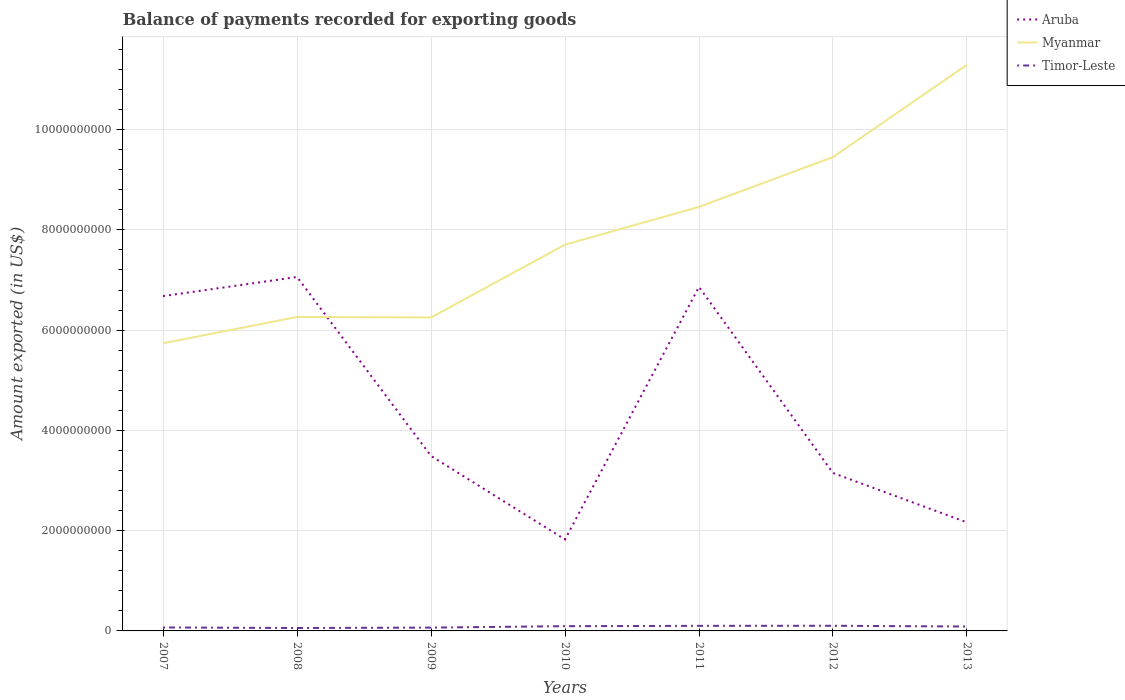Is the number of lines equal to the number of legend labels?
Provide a short and direct response. Yes. Across all years, what is the maximum amount exported in Myanmar?
Give a very brief answer. 5.74e+09. What is the total amount exported in Aruba in the graph?
Ensure brevity in your answer.  -3.82e+08. What is the difference between the highest and the second highest amount exported in Timor-Leste?
Your response must be concise. 4.45e+07. How many years are there in the graph?
Keep it short and to the point. 7. What is the difference between two consecutive major ticks on the Y-axis?
Offer a very short reply. 2.00e+09. How many legend labels are there?
Your answer should be very brief. 3. What is the title of the graph?
Your answer should be compact. Balance of payments recorded for exporting goods. Does "Northern Mariana Islands" appear as one of the legend labels in the graph?
Give a very brief answer. No. What is the label or title of the X-axis?
Ensure brevity in your answer.  Years. What is the label or title of the Y-axis?
Offer a terse response. Amount exported (in US$). What is the Amount exported (in US$) of Aruba in 2007?
Offer a terse response. 6.68e+09. What is the Amount exported (in US$) in Myanmar in 2007?
Your answer should be very brief. 5.74e+09. What is the Amount exported (in US$) in Timor-Leste in 2007?
Your answer should be compact. 6.92e+07. What is the Amount exported (in US$) of Aruba in 2008?
Your response must be concise. 7.06e+09. What is the Amount exported (in US$) in Myanmar in 2008?
Offer a very short reply. 6.26e+09. What is the Amount exported (in US$) of Timor-Leste in 2008?
Your answer should be very brief. 5.81e+07. What is the Amount exported (in US$) of Aruba in 2009?
Your response must be concise. 3.49e+09. What is the Amount exported (in US$) of Myanmar in 2009?
Your answer should be compact. 6.25e+09. What is the Amount exported (in US$) in Timor-Leste in 2009?
Provide a succinct answer. 6.61e+07. What is the Amount exported (in US$) in Aruba in 2010?
Give a very brief answer. 1.82e+09. What is the Amount exported (in US$) in Myanmar in 2010?
Offer a terse response. 7.70e+09. What is the Amount exported (in US$) of Timor-Leste in 2010?
Provide a succinct answer. 9.49e+07. What is the Amount exported (in US$) of Aruba in 2011?
Provide a short and direct response. 6.86e+09. What is the Amount exported (in US$) of Myanmar in 2011?
Ensure brevity in your answer.  8.46e+09. What is the Amount exported (in US$) of Timor-Leste in 2011?
Your answer should be very brief. 1.01e+08. What is the Amount exported (in US$) in Aruba in 2012?
Provide a succinct answer. 3.15e+09. What is the Amount exported (in US$) in Myanmar in 2012?
Make the answer very short. 9.45e+09. What is the Amount exported (in US$) in Timor-Leste in 2012?
Your answer should be compact. 1.03e+08. What is the Amount exported (in US$) of Aruba in 2013?
Your response must be concise. 2.16e+09. What is the Amount exported (in US$) in Myanmar in 2013?
Your answer should be very brief. 1.13e+1. What is the Amount exported (in US$) of Timor-Leste in 2013?
Keep it short and to the point. 8.79e+07. Across all years, what is the maximum Amount exported (in US$) in Aruba?
Your answer should be very brief. 7.06e+09. Across all years, what is the maximum Amount exported (in US$) in Myanmar?
Offer a very short reply. 1.13e+1. Across all years, what is the maximum Amount exported (in US$) in Timor-Leste?
Offer a very short reply. 1.03e+08. Across all years, what is the minimum Amount exported (in US$) in Aruba?
Your answer should be very brief. 1.82e+09. Across all years, what is the minimum Amount exported (in US$) of Myanmar?
Offer a very short reply. 5.74e+09. Across all years, what is the minimum Amount exported (in US$) in Timor-Leste?
Make the answer very short. 5.81e+07. What is the total Amount exported (in US$) in Aruba in the graph?
Give a very brief answer. 3.12e+1. What is the total Amount exported (in US$) in Myanmar in the graph?
Provide a succinct answer. 5.52e+1. What is the total Amount exported (in US$) in Timor-Leste in the graph?
Keep it short and to the point. 5.80e+08. What is the difference between the Amount exported (in US$) of Aruba in 2007 and that in 2008?
Keep it short and to the point. -3.82e+08. What is the difference between the Amount exported (in US$) in Myanmar in 2007 and that in 2008?
Your answer should be compact. -5.25e+08. What is the difference between the Amount exported (in US$) in Timor-Leste in 2007 and that in 2008?
Your answer should be compact. 1.10e+07. What is the difference between the Amount exported (in US$) of Aruba in 2007 and that in 2009?
Offer a terse response. 3.19e+09. What is the difference between the Amount exported (in US$) of Myanmar in 2007 and that in 2009?
Keep it short and to the point. -5.15e+08. What is the difference between the Amount exported (in US$) in Timor-Leste in 2007 and that in 2009?
Keep it short and to the point. 3.01e+06. What is the difference between the Amount exported (in US$) of Aruba in 2007 and that in 2010?
Offer a terse response. 4.85e+09. What is the difference between the Amount exported (in US$) of Myanmar in 2007 and that in 2010?
Make the answer very short. -1.97e+09. What is the difference between the Amount exported (in US$) of Timor-Leste in 2007 and that in 2010?
Keep it short and to the point. -2.57e+07. What is the difference between the Amount exported (in US$) in Aruba in 2007 and that in 2011?
Provide a short and direct response. -1.83e+08. What is the difference between the Amount exported (in US$) in Myanmar in 2007 and that in 2011?
Make the answer very short. -2.72e+09. What is the difference between the Amount exported (in US$) in Timor-Leste in 2007 and that in 2011?
Your answer should be very brief. -3.21e+07. What is the difference between the Amount exported (in US$) in Aruba in 2007 and that in 2012?
Offer a very short reply. 3.53e+09. What is the difference between the Amount exported (in US$) of Myanmar in 2007 and that in 2012?
Ensure brevity in your answer.  -3.71e+09. What is the difference between the Amount exported (in US$) in Timor-Leste in 2007 and that in 2012?
Your response must be concise. -3.35e+07. What is the difference between the Amount exported (in US$) of Aruba in 2007 and that in 2013?
Your answer should be compact. 4.51e+09. What is the difference between the Amount exported (in US$) in Myanmar in 2007 and that in 2013?
Keep it short and to the point. -5.56e+09. What is the difference between the Amount exported (in US$) in Timor-Leste in 2007 and that in 2013?
Keep it short and to the point. -1.87e+07. What is the difference between the Amount exported (in US$) in Aruba in 2008 and that in 2009?
Make the answer very short. 3.57e+09. What is the difference between the Amount exported (in US$) of Myanmar in 2008 and that in 2009?
Keep it short and to the point. 9.44e+06. What is the difference between the Amount exported (in US$) of Timor-Leste in 2008 and that in 2009?
Your response must be concise. -8.01e+06. What is the difference between the Amount exported (in US$) in Aruba in 2008 and that in 2010?
Keep it short and to the point. 5.24e+09. What is the difference between the Amount exported (in US$) in Myanmar in 2008 and that in 2010?
Provide a succinct answer. -1.44e+09. What is the difference between the Amount exported (in US$) in Timor-Leste in 2008 and that in 2010?
Offer a very short reply. -3.67e+07. What is the difference between the Amount exported (in US$) in Aruba in 2008 and that in 2011?
Your answer should be compact. 1.99e+08. What is the difference between the Amount exported (in US$) in Myanmar in 2008 and that in 2011?
Offer a terse response. -2.20e+09. What is the difference between the Amount exported (in US$) in Timor-Leste in 2008 and that in 2011?
Provide a short and direct response. -4.31e+07. What is the difference between the Amount exported (in US$) of Aruba in 2008 and that in 2012?
Your response must be concise. 3.91e+09. What is the difference between the Amount exported (in US$) of Myanmar in 2008 and that in 2012?
Offer a very short reply. -3.19e+09. What is the difference between the Amount exported (in US$) of Timor-Leste in 2008 and that in 2012?
Your answer should be very brief. -4.45e+07. What is the difference between the Amount exported (in US$) in Aruba in 2008 and that in 2013?
Your answer should be very brief. 4.89e+09. What is the difference between the Amount exported (in US$) in Myanmar in 2008 and that in 2013?
Ensure brevity in your answer.  -5.03e+09. What is the difference between the Amount exported (in US$) of Timor-Leste in 2008 and that in 2013?
Provide a short and direct response. -2.97e+07. What is the difference between the Amount exported (in US$) of Aruba in 2009 and that in 2010?
Provide a succinct answer. 1.67e+09. What is the difference between the Amount exported (in US$) in Myanmar in 2009 and that in 2010?
Your answer should be compact. -1.45e+09. What is the difference between the Amount exported (in US$) in Timor-Leste in 2009 and that in 2010?
Your response must be concise. -2.87e+07. What is the difference between the Amount exported (in US$) in Aruba in 2009 and that in 2011?
Give a very brief answer. -3.37e+09. What is the difference between the Amount exported (in US$) of Myanmar in 2009 and that in 2011?
Your response must be concise. -2.20e+09. What is the difference between the Amount exported (in US$) in Timor-Leste in 2009 and that in 2011?
Provide a short and direct response. -3.51e+07. What is the difference between the Amount exported (in US$) of Aruba in 2009 and that in 2012?
Ensure brevity in your answer.  3.40e+08. What is the difference between the Amount exported (in US$) in Myanmar in 2009 and that in 2012?
Your response must be concise. -3.20e+09. What is the difference between the Amount exported (in US$) in Timor-Leste in 2009 and that in 2012?
Your answer should be compact. -3.65e+07. What is the difference between the Amount exported (in US$) in Aruba in 2009 and that in 2013?
Offer a terse response. 1.33e+09. What is the difference between the Amount exported (in US$) in Myanmar in 2009 and that in 2013?
Ensure brevity in your answer.  -5.04e+09. What is the difference between the Amount exported (in US$) in Timor-Leste in 2009 and that in 2013?
Make the answer very short. -2.17e+07. What is the difference between the Amount exported (in US$) in Aruba in 2010 and that in 2011?
Offer a terse response. -5.04e+09. What is the difference between the Amount exported (in US$) in Myanmar in 2010 and that in 2011?
Your answer should be compact. -7.54e+08. What is the difference between the Amount exported (in US$) in Timor-Leste in 2010 and that in 2011?
Give a very brief answer. -6.37e+06. What is the difference between the Amount exported (in US$) of Aruba in 2010 and that in 2012?
Provide a succinct answer. -1.33e+09. What is the difference between the Amount exported (in US$) in Myanmar in 2010 and that in 2012?
Keep it short and to the point. -1.75e+09. What is the difference between the Amount exported (in US$) of Timor-Leste in 2010 and that in 2012?
Your response must be concise. -7.80e+06. What is the difference between the Amount exported (in US$) of Aruba in 2010 and that in 2013?
Your answer should be compact. -3.40e+08. What is the difference between the Amount exported (in US$) of Myanmar in 2010 and that in 2013?
Give a very brief answer. -3.59e+09. What is the difference between the Amount exported (in US$) in Timor-Leste in 2010 and that in 2013?
Keep it short and to the point. 7.03e+06. What is the difference between the Amount exported (in US$) of Aruba in 2011 and that in 2012?
Make the answer very short. 3.71e+09. What is the difference between the Amount exported (in US$) in Myanmar in 2011 and that in 2012?
Give a very brief answer. -9.94e+08. What is the difference between the Amount exported (in US$) in Timor-Leste in 2011 and that in 2012?
Give a very brief answer. -1.43e+06. What is the difference between the Amount exported (in US$) of Aruba in 2011 and that in 2013?
Your response must be concise. 4.70e+09. What is the difference between the Amount exported (in US$) of Myanmar in 2011 and that in 2013?
Keep it short and to the point. -2.84e+09. What is the difference between the Amount exported (in US$) of Timor-Leste in 2011 and that in 2013?
Your answer should be compact. 1.34e+07. What is the difference between the Amount exported (in US$) of Aruba in 2012 and that in 2013?
Provide a succinct answer. 9.85e+08. What is the difference between the Amount exported (in US$) of Myanmar in 2012 and that in 2013?
Offer a very short reply. -1.84e+09. What is the difference between the Amount exported (in US$) in Timor-Leste in 2012 and that in 2013?
Offer a very short reply. 1.48e+07. What is the difference between the Amount exported (in US$) of Aruba in 2007 and the Amount exported (in US$) of Myanmar in 2008?
Provide a succinct answer. 4.16e+08. What is the difference between the Amount exported (in US$) in Aruba in 2007 and the Amount exported (in US$) in Timor-Leste in 2008?
Make the answer very short. 6.62e+09. What is the difference between the Amount exported (in US$) in Myanmar in 2007 and the Amount exported (in US$) in Timor-Leste in 2008?
Your answer should be compact. 5.68e+09. What is the difference between the Amount exported (in US$) of Aruba in 2007 and the Amount exported (in US$) of Myanmar in 2009?
Make the answer very short. 4.25e+08. What is the difference between the Amount exported (in US$) in Aruba in 2007 and the Amount exported (in US$) in Timor-Leste in 2009?
Provide a succinct answer. 6.61e+09. What is the difference between the Amount exported (in US$) in Myanmar in 2007 and the Amount exported (in US$) in Timor-Leste in 2009?
Offer a very short reply. 5.67e+09. What is the difference between the Amount exported (in US$) in Aruba in 2007 and the Amount exported (in US$) in Myanmar in 2010?
Provide a short and direct response. -1.03e+09. What is the difference between the Amount exported (in US$) in Aruba in 2007 and the Amount exported (in US$) in Timor-Leste in 2010?
Your answer should be compact. 6.58e+09. What is the difference between the Amount exported (in US$) of Myanmar in 2007 and the Amount exported (in US$) of Timor-Leste in 2010?
Keep it short and to the point. 5.64e+09. What is the difference between the Amount exported (in US$) in Aruba in 2007 and the Amount exported (in US$) in Myanmar in 2011?
Your answer should be compact. -1.78e+09. What is the difference between the Amount exported (in US$) of Aruba in 2007 and the Amount exported (in US$) of Timor-Leste in 2011?
Provide a short and direct response. 6.58e+09. What is the difference between the Amount exported (in US$) of Myanmar in 2007 and the Amount exported (in US$) of Timor-Leste in 2011?
Provide a succinct answer. 5.64e+09. What is the difference between the Amount exported (in US$) of Aruba in 2007 and the Amount exported (in US$) of Myanmar in 2012?
Keep it short and to the point. -2.77e+09. What is the difference between the Amount exported (in US$) in Aruba in 2007 and the Amount exported (in US$) in Timor-Leste in 2012?
Ensure brevity in your answer.  6.58e+09. What is the difference between the Amount exported (in US$) of Myanmar in 2007 and the Amount exported (in US$) of Timor-Leste in 2012?
Provide a succinct answer. 5.63e+09. What is the difference between the Amount exported (in US$) of Aruba in 2007 and the Amount exported (in US$) of Myanmar in 2013?
Your answer should be compact. -4.62e+09. What is the difference between the Amount exported (in US$) in Aruba in 2007 and the Amount exported (in US$) in Timor-Leste in 2013?
Offer a very short reply. 6.59e+09. What is the difference between the Amount exported (in US$) in Myanmar in 2007 and the Amount exported (in US$) in Timor-Leste in 2013?
Offer a very short reply. 5.65e+09. What is the difference between the Amount exported (in US$) in Aruba in 2008 and the Amount exported (in US$) in Myanmar in 2009?
Your answer should be compact. 8.07e+08. What is the difference between the Amount exported (in US$) in Aruba in 2008 and the Amount exported (in US$) in Timor-Leste in 2009?
Make the answer very short. 6.99e+09. What is the difference between the Amount exported (in US$) in Myanmar in 2008 and the Amount exported (in US$) in Timor-Leste in 2009?
Your answer should be very brief. 6.20e+09. What is the difference between the Amount exported (in US$) of Aruba in 2008 and the Amount exported (in US$) of Myanmar in 2010?
Keep it short and to the point. -6.44e+08. What is the difference between the Amount exported (in US$) of Aruba in 2008 and the Amount exported (in US$) of Timor-Leste in 2010?
Provide a succinct answer. 6.96e+09. What is the difference between the Amount exported (in US$) in Myanmar in 2008 and the Amount exported (in US$) in Timor-Leste in 2010?
Your answer should be very brief. 6.17e+09. What is the difference between the Amount exported (in US$) in Aruba in 2008 and the Amount exported (in US$) in Myanmar in 2011?
Your answer should be compact. -1.40e+09. What is the difference between the Amount exported (in US$) of Aruba in 2008 and the Amount exported (in US$) of Timor-Leste in 2011?
Give a very brief answer. 6.96e+09. What is the difference between the Amount exported (in US$) in Myanmar in 2008 and the Amount exported (in US$) in Timor-Leste in 2011?
Your response must be concise. 6.16e+09. What is the difference between the Amount exported (in US$) in Aruba in 2008 and the Amount exported (in US$) in Myanmar in 2012?
Provide a short and direct response. -2.39e+09. What is the difference between the Amount exported (in US$) in Aruba in 2008 and the Amount exported (in US$) in Timor-Leste in 2012?
Make the answer very short. 6.96e+09. What is the difference between the Amount exported (in US$) in Myanmar in 2008 and the Amount exported (in US$) in Timor-Leste in 2012?
Offer a very short reply. 6.16e+09. What is the difference between the Amount exported (in US$) in Aruba in 2008 and the Amount exported (in US$) in Myanmar in 2013?
Your response must be concise. -4.23e+09. What is the difference between the Amount exported (in US$) of Aruba in 2008 and the Amount exported (in US$) of Timor-Leste in 2013?
Offer a very short reply. 6.97e+09. What is the difference between the Amount exported (in US$) in Myanmar in 2008 and the Amount exported (in US$) in Timor-Leste in 2013?
Your answer should be very brief. 6.17e+09. What is the difference between the Amount exported (in US$) of Aruba in 2009 and the Amount exported (in US$) of Myanmar in 2010?
Ensure brevity in your answer.  -4.21e+09. What is the difference between the Amount exported (in US$) of Aruba in 2009 and the Amount exported (in US$) of Timor-Leste in 2010?
Provide a succinct answer. 3.40e+09. What is the difference between the Amount exported (in US$) of Myanmar in 2009 and the Amount exported (in US$) of Timor-Leste in 2010?
Your response must be concise. 6.16e+09. What is the difference between the Amount exported (in US$) in Aruba in 2009 and the Amount exported (in US$) in Myanmar in 2011?
Your response must be concise. -4.97e+09. What is the difference between the Amount exported (in US$) in Aruba in 2009 and the Amount exported (in US$) in Timor-Leste in 2011?
Offer a very short reply. 3.39e+09. What is the difference between the Amount exported (in US$) in Myanmar in 2009 and the Amount exported (in US$) in Timor-Leste in 2011?
Your answer should be compact. 6.15e+09. What is the difference between the Amount exported (in US$) in Aruba in 2009 and the Amount exported (in US$) in Myanmar in 2012?
Give a very brief answer. -5.96e+09. What is the difference between the Amount exported (in US$) of Aruba in 2009 and the Amount exported (in US$) of Timor-Leste in 2012?
Give a very brief answer. 3.39e+09. What is the difference between the Amount exported (in US$) in Myanmar in 2009 and the Amount exported (in US$) in Timor-Leste in 2012?
Give a very brief answer. 6.15e+09. What is the difference between the Amount exported (in US$) of Aruba in 2009 and the Amount exported (in US$) of Myanmar in 2013?
Offer a very short reply. -7.80e+09. What is the difference between the Amount exported (in US$) in Aruba in 2009 and the Amount exported (in US$) in Timor-Leste in 2013?
Offer a terse response. 3.40e+09. What is the difference between the Amount exported (in US$) in Myanmar in 2009 and the Amount exported (in US$) in Timor-Leste in 2013?
Ensure brevity in your answer.  6.16e+09. What is the difference between the Amount exported (in US$) in Aruba in 2010 and the Amount exported (in US$) in Myanmar in 2011?
Provide a succinct answer. -6.63e+09. What is the difference between the Amount exported (in US$) of Aruba in 2010 and the Amount exported (in US$) of Timor-Leste in 2011?
Your response must be concise. 1.72e+09. What is the difference between the Amount exported (in US$) in Myanmar in 2010 and the Amount exported (in US$) in Timor-Leste in 2011?
Your response must be concise. 7.60e+09. What is the difference between the Amount exported (in US$) in Aruba in 2010 and the Amount exported (in US$) in Myanmar in 2012?
Your answer should be compact. -7.63e+09. What is the difference between the Amount exported (in US$) in Aruba in 2010 and the Amount exported (in US$) in Timor-Leste in 2012?
Your answer should be compact. 1.72e+09. What is the difference between the Amount exported (in US$) of Myanmar in 2010 and the Amount exported (in US$) of Timor-Leste in 2012?
Offer a terse response. 7.60e+09. What is the difference between the Amount exported (in US$) in Aruba in 2010 and the Amount exported (in US$) in Myanmar in 2013?
Keep it short and to the point. -9.47e+09. What is the difference between the Amount exported (in US$) of Aruba in 2010 and the Amount exported (in US$) of Timor-Leste in 2013?
Offer a terse response. 1.74e+09. What is the difference between the Amount exported (in US$) in Myanmar in 2010 and the Amount exported (in US$) in Timor-Leste in 2013?
Provide a short and direct response. 7.62e+09. What is the difference between the Amount exported (in US$) in Aruba in 2011 and the Amount exported (in US$) in Myanmar in 2012?
Offer a terse response. -2.59e+09. What is the difference between the Amount exported (in US$) in Aruba in 2011 and the Amount exported (in US$) in Timor-Leste in 2012?
Make the answer very short. 6.76e+09. What is the difference between the Amount exported (in US$) of Myanmar in 2011 and the Amount exported (in US$) of Timor-Leste in 2012?
Provide a succinct answer. 8.35e+09. What is the difference between the Amount exported (in US$) in Aruba in 2011 and the Amount exported (in US$) in Myanmar in 2013?
Offer a terse response. -4.43e+09. What is the difference between the Amount exported (in US$) of Aruba in 2011 and the Amount exported (in US$) of Timor-Leste in 2013?
Give a very brief answer. 6.77e+09. What is the difference between the Amount exported (in US$) in Myanmar in 2011 and the Amount exported (in US$) in Timor-Leste in 2013?
Ensure brevity in your answer.  8.37e+09. What is the difference between the Amount exported (in US$) of Aruba in 2012 and the Amount exported (in US$) of Myanmar in 2013?
Ensure brevity in your answer.  -8.14e+09. What is the difference between the Amount exported (in US$) in Aruba in 2012 and the Amount exported (in US$) in Timor-Leste in 2013?
Give a very brief answer. 3.06e+09. What is the difference between the Amount exported (in US$) in Myanmar in 2012 and the Amount exported (in US$) in Timor-Leste in 2013?
Keep it short and to the point. 9.36e+09. What is the average Amount exported (in US$) of Aruba per year?
Ensure brevity in your answer.  4.46e+09. What is the average Amount exported (in US$) in Myanmar per year?
Your response must be concise. 7.88e+09. What is the average Amount exported (in US$) in Timor-Leste per year?
Give a very brief answer. 8.29e+07. In the year 2007, what is the difference between the Amount exported (in US$) of Aruba and Amount exported (in US$) of Myanmar?
Give a very brief answer. 9.40e+08. In the year 2007, what is the difference between the Amount exported (in US$) in Aruba and Amount exported (in US$) in Timor-Leste?
Your answer should be very brief. 6.61e+09. In the year 2007, what is the difference between the Amount exported (in US$) of Myanmar and Amount exported (in US$) of Timor-Leste?
Make the answer very short. 5.67e+09. In the year 2008, what is the difference between the Amount exported (in US$) of Aruba and Amount exported (in US$) of Myanmar?
Offer a very short reply. 7.98e+08. In the year 2008, what is the difference between the Amount exported (in US$) in Aruba and Amount exported (in US$) in Timor-Leste?
Give a very brief answer. 7.00e+09. In the year 2008, what is the difference between the Amount exported (in US$) of Myanmar and Amount exported (in US$) of Timor-Leste?
Your answer should be compact. 6.20e+09. In the year 2009, what is the difference between the Amount exported (in US$) of Aruba and Amount exported (in US$) of Myanmar?
Ensure brevity in your answer.  -2.76e+09. In the year 2009, what is the difference between the Amount exported (in US$) in Aruba and Amount exported (in US$) in Timor-Leste?
Offer a very short reply. 3.42e+09. In the year 2009, what is the difference between the Amount exported (in US$) of Myanmar and Amount exported (in US$) of Timor-Leste?
Your answer should be compact. 6.19e+09. In the year 2010, what is the difference between the Amount exported (in US$) of Aruba and Amount exported (in US$) of Myanmar?
Give a very brief answer. -5.88e+09. In the year 2010, what is the difference between the Amount exported (in US$) of Aruba and Amount exported (in US$) of Timor-Leste?
Your answer should be compact. 1.73e+09. In the year 2010, what is the difference between the Amount exported (in US$) of Myanmar and Amount exported (in US$) of Timor-Leste?
Your answer should be compact. 7.61e+09. In the year 2011, what is the difference between the Amount exported (in US$) in Aruba and Amount exported (in US$) in Myanmar?
Your answer should be compact. -1.60e+09. In the year 2011, what is the difference between the Amount exported (in US$) in Aruba and Amount exported (in US$) in Timor-Leste?
Your response must be concise. 6.76e+09. In the year 2011, what is the difference between the Amount exported (in US$) in Myanmar and Amount exported (in US$) in Timor-Leste?
Your answer should be very brief. 8.36e+09. In the year 2012, what is the difference between the Amount exported (in US$) in Aruba and Amount exported (in US$) in Myanmar?
Keep it short and to the point. -6.30e+09. In the year 2012, what is the difference between the Amount exported (in US$) in Aruba and Amount exported (in US$) in Timor-Leste?
Your answer should be compact. 3.05e+09. In the year 2012, what is the difference between the Amount exported (in US$) in Myanmar and Amount exported (in US$) in Timor-Leste?
Provide a short and direct response. 9.35e+09. In the year 2013, what is the difference between the Amount exported (in US$) of Aruba and Amount exported (in US$) of Myanmar?
Keep it short and to the point. -9.13e+09. In the year 2013, what is the difference between the Amount exported (in US$) of Aruba and Amount exported (in US$) of Timor-Leste?
Provide a succinct answer. 2.08e+09. In the year 2013, what is the difference between the Amount exported (in US$) of Myanmar and Amount exported (in US$) of Timor-Leste?
Give a very brief answer. 1.12e+1. What is the ratio of the Amount exported (in US$) in Aruba in 2007 to that in 2008?
Provide a short and direct response. 0.95. What is the ratio of the Amount exported (in US$) of Myanmar in 2007 to that in 2008?
Your response must be concise. 0.92. What is the ratio of the Amount exported (in US$) in Timor-Leste in 2007 to that in 2008?
Provide a short and direct response. 1.19. What is the ratio of the Amount exported (in US$) in Aruba in 2007 to that in 2009?
Offer a very short reply. 1.91. What is the ratio of the Amount exported (in US$) of Myanmar in 2007 to that in 2009?
Provide a succinct answer. 0.92. What is the ratio of the Amount exported (in US$) in Timor-Leste in 2007 to that in 2009?
Your response must be concise. 1.05. What is the ratio of the Amount exported (in US$) in Aruba in 2007 to that in 2010?
Your response must be concise. 3.66. What is the ratio of the Amount exported (in US$) of Myanmar in 2007 to that in 2010?
Offer a terse response. 0.74. What is the ratio of the Amount exported (in US$) in Timor-Leste in 2007 to that in 2010?
Offer a terse response. 0.73. What is the ratio of the Amount exported (in US$) of Aruba in 2007 to that in 2011?
Keep it short and to the point. 0.97. What is the ratio of the Amount exported (in US$) in Myanmar in 2007 to that in 2011?
Keep it short and to the point. 0.68. What is the ratio of the Amount exported (in US$) of Timor-Leste in 2007 to that in 2011?
Keep it short and to the point. 0.68. What is the ratio of the Amount exported (in US$) in Aruba in 2007 to that in 2012?
Ensure brevity in your answer.  2.12. What is the ratio of the Amount exported (in US$) in Myanmar in 2007 to that in 2012?
Ensure brevity in your answer.  0.61. What is the ratio of the Amount exported (in US$) of Timor-Leste in 2007 to that in 2012?
Ensure brevity in your answer.  0.67. What is the ratio of the Amount exported (in US$) in Aruba in 2007 to that in 2013?
Provide a succinct answer. 3.08. What is the ratio of the Amount exported (in US$) in Myanmar in 2007 to that in 2013?
Your response must be concise. 0.51. What is the ratio of the Amount exported (in US$) of Timor-Leste in 2007 to that in 2013?
Your response must be concise. 0.79. What is the ratio of the Amount exported (in US$) in Aruba in 2008 to that in 2009?
Ensure brevity in your answer.  2.02. What is the ratio of the Amount exported (in US$) of Myanmar in 2008 to that in 2009?
Offer a very short reply. 1. What is the ratio of the Amount exported (in US$) in Timor-Leste in 2008 to that in 2009?
Give a very brief answer. 0.88. What is the ratio of the Amount exported (in US$) of Aruba in 2008 to that in 2010?
Offer a very short reply. 3.87. What is the ratio of the Amount exported (in US$) in Myanmar in 2008 to that in 2010?
Give a very brief answer. 0.81. What is the ratio of the Amount exported (in US$) in Timor-Leste in 2008 to that in 2010?
Keep it short and to the point. 0.61. What is the ratio of the Amount exported (in US$) of Aruba in 2008 to that in 2011?
Offer a very short reply. 1.03. What is the ratio of the Amount exported (in US$) in Myanmar in 2008 to that in 2011?
Your answer should be compact. 0.74. What is the ratio of the Amount exported (in US$) in Timor-Leste in 2008 to that in 2011?
Keep it short and to the point. 0.57. What is the ratio of the Amount exported (in US$) in Aruba in 2008 to that in 2012?
Give a very brief answer. 2.24. What is the ratio of the Amount exported (in US$) of Myanmar in 2008 to that in 2012?
Make the answer very short. 0.66. What is the ratio of the Amount exported (in US$) of Timor-Leste in 2008 to that in 2012?
Your answer should be very brief. 0.57. What is the ratio of the Amount exported (in US$) in Aruba in 2008 to that in 2013?
Give a very brief answer. 3.26. What is the ratio of the Amount exported (in US$) in Myanmar in 2008 to that in 2013?
Provide a succinct answer. 0.55. What is the ratio of the Amount exported (in US$) of Timor-Leste in 2008 to that in 2013?
Your response must be concise. 0.66. What is the ratio of the Amount exported (in US$) of Aruba in 2009 to that in 2010?
Provide a succinct answer. 1.91. What is the ratio of the Amount exported (in US$) of Myanmar in 2009 to that in 2010?
Provide a short and direct response. 0.81. What is the ratio of the Amount exported (in US$) in Timor-Leste in 2009 to that in 2010?
Give a very brief answer. 0.7. What is the ratio of the Amount exported (in US$) of Aruba in 2009 to that in 2011?
Provide a short and direct response. 0.51. What is the ratio of the Amount exported (in US$) of Myanmar in 2009 to that in 2011?
Your response must be concise. 0.74. What is the ratio of the Amount exported (in US$) in Timor-Leste in 2009 to that in 2011?
Offer a very short reply. 0.65. What is the ratio of the Amount exported (in US$) in Aruba in 2009 to that in 2012?
Provide a succinct answer. 1.11. What is the ratio of the Amount exported (in US$) in Myanmar in 2009 to that in 2012?
Your answer should be compact. 0.66. What is the ratio of the Amount exported (in US$) in Timor-Leste in 2009 to that in 2012?
Ensure brevity in your answer.  0.64. What is the ratio of the Amount exported (in US$) in Aruba in 2009 to that in 2013?
Ensure brevity in your answer.  1.61. What is the ratio of the Amount exported (in US$) in Myanmar in 2009 to that in 2013?
Give a very brief answer. 0.55. What is the ratio of the Amount exported (in US$) in Timor-Leste in 2009 to that in 2013?
Provide a succinct answer. 0.75. What is the ratio of the Amount exported (in US$) of Aruba in 2010 to that in 2011?
Offer a terse response. 0.27. What is the ratio of the Amount exported (in US$) in Myanmar in 2010 to that in 2011?
Keep it short and to the point. 0.91. What is the ratio of the Amount exported (in US$) in Timor-Leste in 2010 to that in 2011?
Offer a very short reply. 0.94. What is the ratio of the Amount exported (in US$) in Aruba in 2010 to that in 2012?
Your response must be concise. 0.58. What is the ratio of the Amount exported (in US$) in Myanmar in 2010 to that in 2012?
Keep it short and to the point. 0.82. What is the ratio of the Amount exported (in US$) in Timor-Leste in 2010 to that in 2012?
Your response must be concise. 0.92. What is the ratio of the Amount exported (in US$) of Aruba in 2010 to that in 2013?
Give a very brief answer. 0.84. What is the ratio of the Amount exported (in US$) in Myanmar in 2010 to that in 2013?
Make the answer very short. 0.68. What is the ratio of the Amount exported (in US$) in Timor-Leste in 2010 to that in 2013?
Offer a very short reply. 1.08. What is the ratio of the Amount exported (in US$) of Aruba in 2011 to that in 2012?
Ensure brevity in your answer.  2.18. What is the ratio of the Amount exported (in US$) of Myanmar in 2011 to that in 2012?
Make the answer very short. 0.89. What is the ratio of the Amount exported (in US$) in Timor-Leste in 2011 to that in 2012?
Offer a terse response. 0.99. What is the ratio of the Amount exported (in US$) of Aruba in 2011 to that in 2013?
Give a very brief answer. 3.17. What is the ratio of the Amount exported (in US$) of Myanmar in 2011 to that in 2013?
Offer a very short reply. 0.75. What is the ratio of the Amount exported (in US$) of Timor-Leste in 2011 to that in 2013?
Your answer should be compact. 1.15. What is the ratio of the Amount exported (in US$) in Aruba in 2012 to that in 2013?
Offer a very short reply. 1.45. What is the ratio of the Amount exported (in US$) in Myanmar in 2012 to that in 2013?
Make the answer very short. 0.84. What is the ratio of the Amount exported (in US$) in Timor-Leste in 2012 to that in 2013?
Give a very brief answer. 1.17. What is the difference between the highest and the second highest Amount exported (in US$) of Aruba?
Ensure brevity in your answer.  1.99e+08. What is the difference between the highest and the second highest Amount exported (in US$) in Myanmar?
Offer a very short reply. 1.84e+09. What is the difference between the highest and the second highest Amount exported (in US$) in Timor-Leste?
Make the answer very short. 1.43e+06. What is the difference between the highest and the lowest Amount exported (in US$) in Aruba?
Offer a very short reply. 5.24e+09. What is the difference between the highest and the lowest Amount exported (in US$) of Myanmar?
Offer a very short reply. 5.56e+09. What is the difference between the highest and the lowest Amount exported (in US$) in Timor-Leste?
Your answer should be very brief. 4.45e+07. 